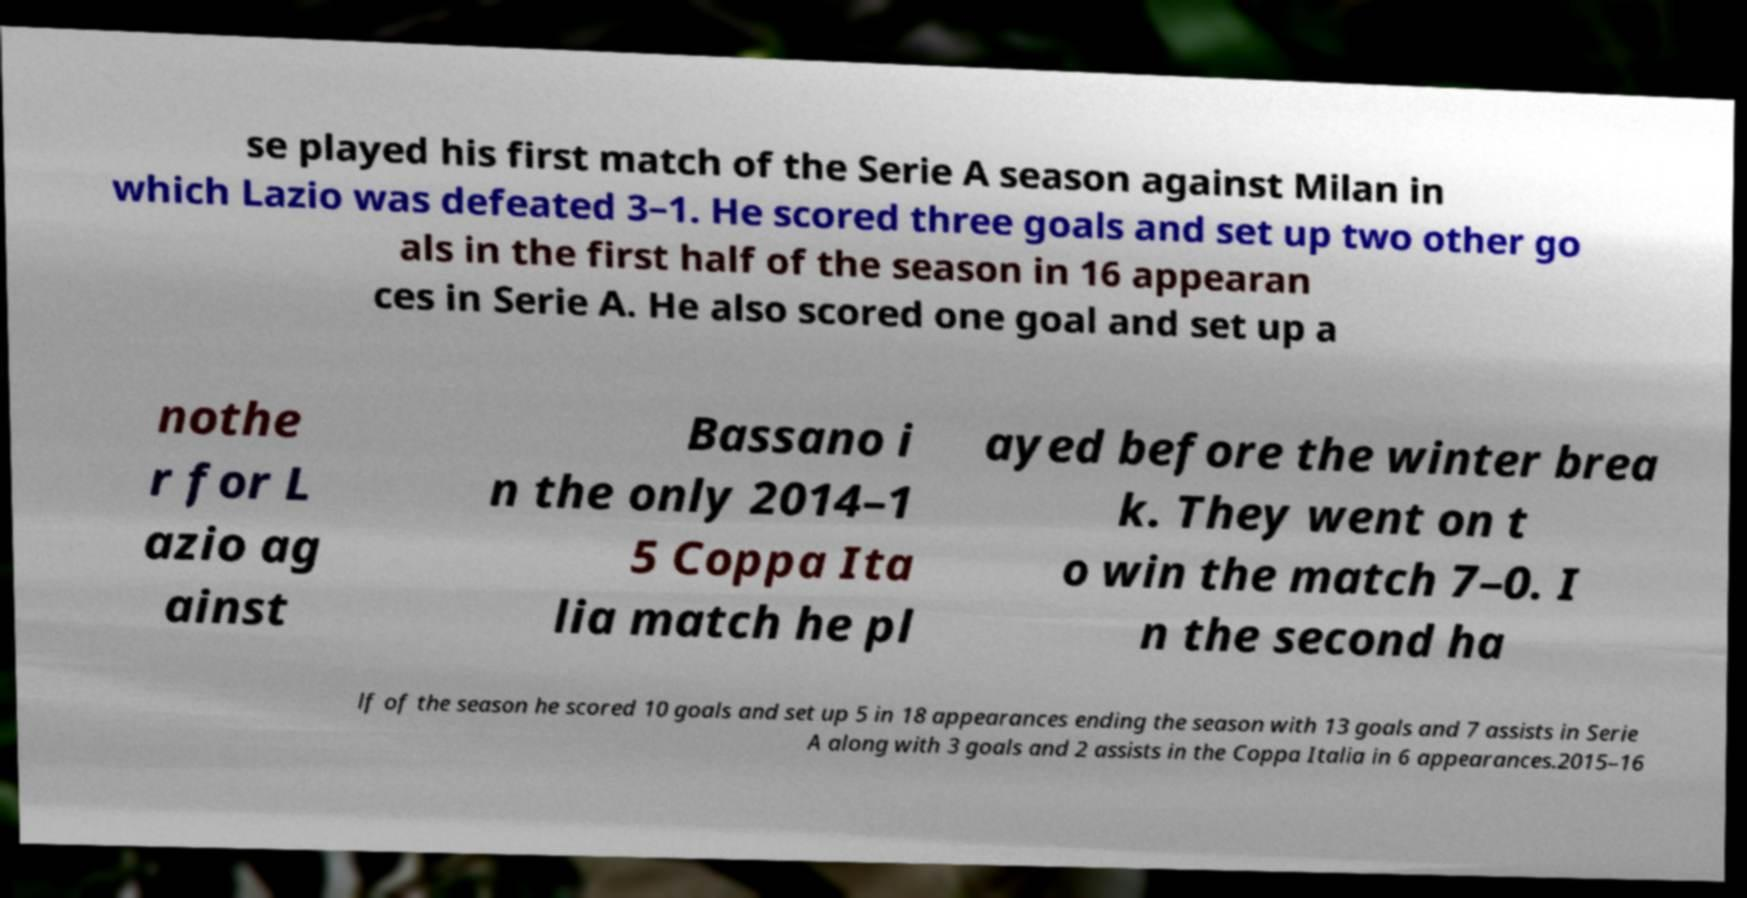Can you read and provide the text displayed in the image?This photo seems to have some interesting text. Can you extract and type it out for me? se played his first match of the Serie A season against Milan in which Lazio was defeated 3–1. He scored three goals and set up two other go als in the first half of the season in 16 appearan ces in Serie A. He also scored one goal and set up a nothe r for L azio ag ainst Bassano i n the only 2014–1 5 Coppa Ita lia match he pl ayed before the winter brea k. They went on t o win the match 7–0. I n the second ha lf of the season he scored 10 goals and set up 5 in 18 appearances ending the season with 13 goals and 7 assists in Serie A along with 3 goals and 2 assists in the Coppa Italia in 6 appearances.2015–16 